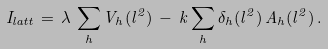Convert formula to latex. <formula><loc_0><loc_0><loc_500><loc_500>I _ { l a t t } \, = \, \lambda \, \sum _ { h } V _ { h } ( l ^ { 2 } ) \, - \, k \sum _ { h } \delta _ { h } ( l ^ { 2 } ) \, A _ { h } ( l ^ { 2 } ) \, .</formula> 